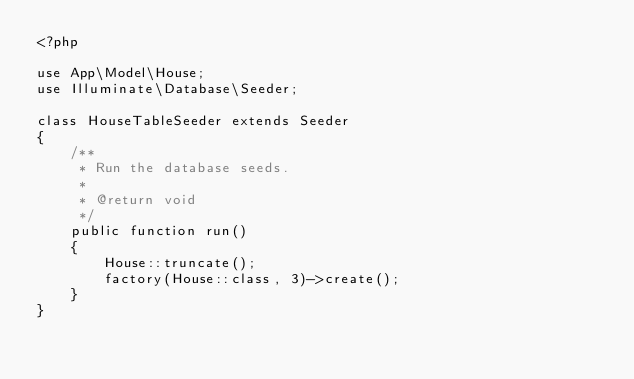Convert code to text. <code><loc_0><loc_0><loc_500><loc_500><_PHP_><?php

use App\Model\House;
use Illuminate\Database\Seeder;

class HouseTableSeeder extends Seeder
{
    /**
     * Run the database seeds.
     *
     * @return void
     */
    public function run()
    {
        House::truncate();
        factory(House::class, 3)->create();
    }
}
</code> 